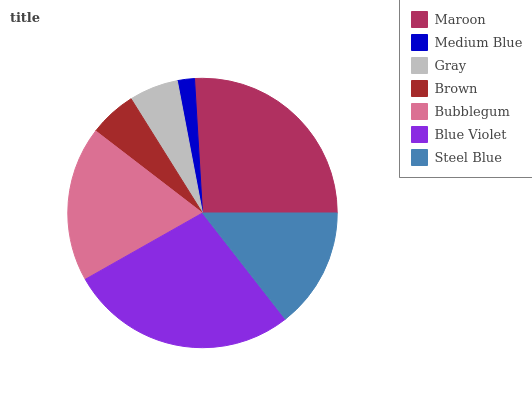Is Medium Blue the minimum?
Answer yes or no. Yes. Is Blue Violet the maximum?
Answer yes or no. Yes. Is Gray the minimum?
Answer yes or no. No. Is Gray the maximum?
Answer yes or no. No. Is Gray greater than Medium Blue?
Answer yes or no. Yes. Is Medium Blue less than Gray?
Answer yes or no. Yes. Is Medium Blue greater than Gray?
Answer yes or no. No. Is Gray less than Medium Blue?
Answer yes or no. No. Is Steel Blue the high median?
Answer yes or no. Yes. Is Steel Blue the low median?
Answer yes or no. Yes. Is Blue Violet the high median?
Answer yes or no. No. Is Maroon the low median?
Answer yes or no. No. 